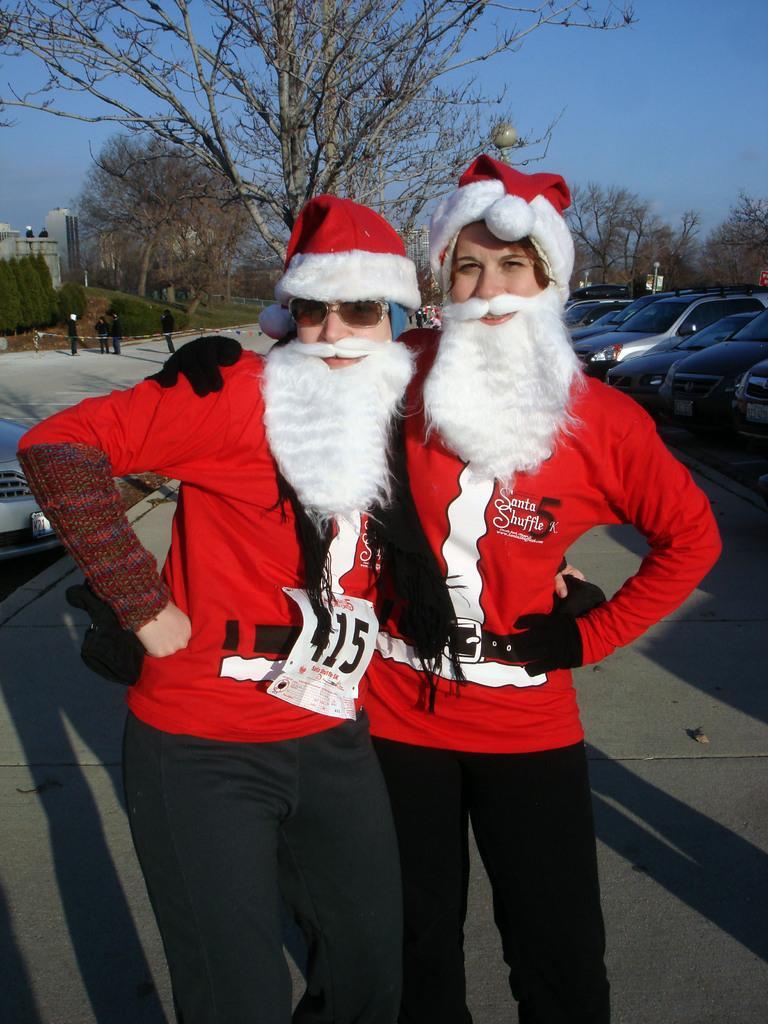Could you give a brief overview of what you see in this image? In this picture we can see two people wore costumes, standing on the ground and at the back of them we can see vehicles, trees, building, some people and in the background we can see the sky. 